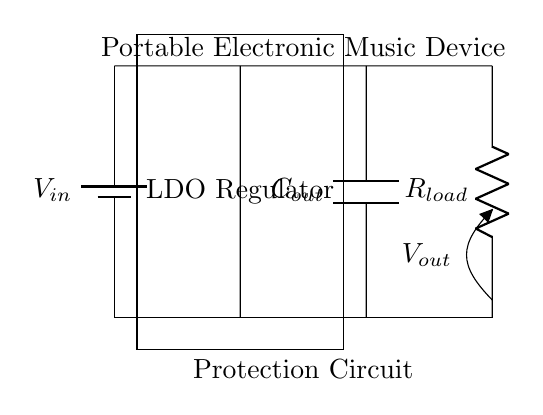What is the input voltage source labeled as? The input voltage source in the circuit is identified as V in, which is shown in the diagram next to the battery symbol.
Answer: V in What component regulates the voltage in this circuit? The component responsible for voltage regulation is labeled as the LDO Regulator in the diagram, which is seen between the input and output sections.
Answer: LDO Regulator What type of load is represented in the circuit? The load shown in the circuit is a resistor labeled as R load, which draws current from the output of the voltage regulator.
Answer: R load How many capacitors are present in this circuit diagram? There is one capacitor in the circuit, labeled as C out, located on the output side, functioning to filter the voltage output.
Answer: 1 What does the output voltage label indicate? The output voltage is indicated by V out on the circuit diagram, marking the voltage available at the terminal connected to the load.
Answer: V out Why is a capacitor placed at the output of the regulator? The capacitor at the output, labeled C out, stabilizes the output voltage by smoothing out fluctuations resulting from rapid load changes, ensuring a consistent voltage supply.
Answer: Stabilization What is the purpose of this protection circuit based on the context? The purpose of the protection circuit as part of the overall design is to safeguard the connected electronic device from over-voltage and provide stable power for performance and safety.
Answer: Safeguard 